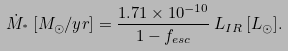<formula> <loc_0><loc_0><loc_500><loc_500>\dot { M } _ { ^ { * } } \, [ M _ { \odot } / y r ] = \frac { 1 . 7 1 \times 1 0 ^ { - 1 0 } } { 1 - f _ { e s c } } \, L _ { I R } \, [ L _ { \odot } ] .</formula> 